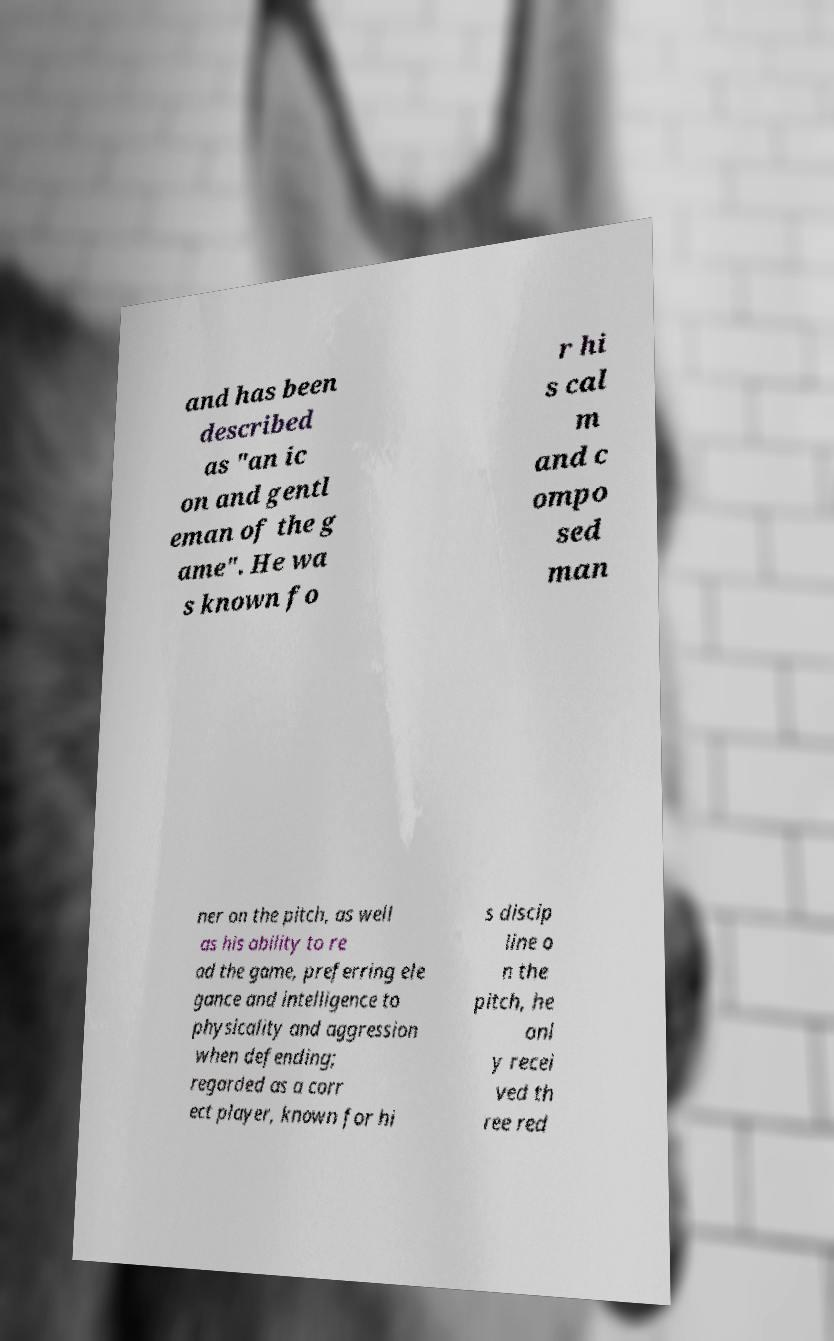For documentation purposes, I need the text within this image transcribed. Could you provide that? and has been described as "an ic on and gentl eman of the g ame". He wa s known fo r hi s cal m and c ompo sed man ner on the pitch, as well as his ability to re ad the game, preferring ele gance and intelligence to physicality and aggression when defending; regarded as a corr ect player, known for hi s discip line o n the pitch, he onl y recei ved th ree red 